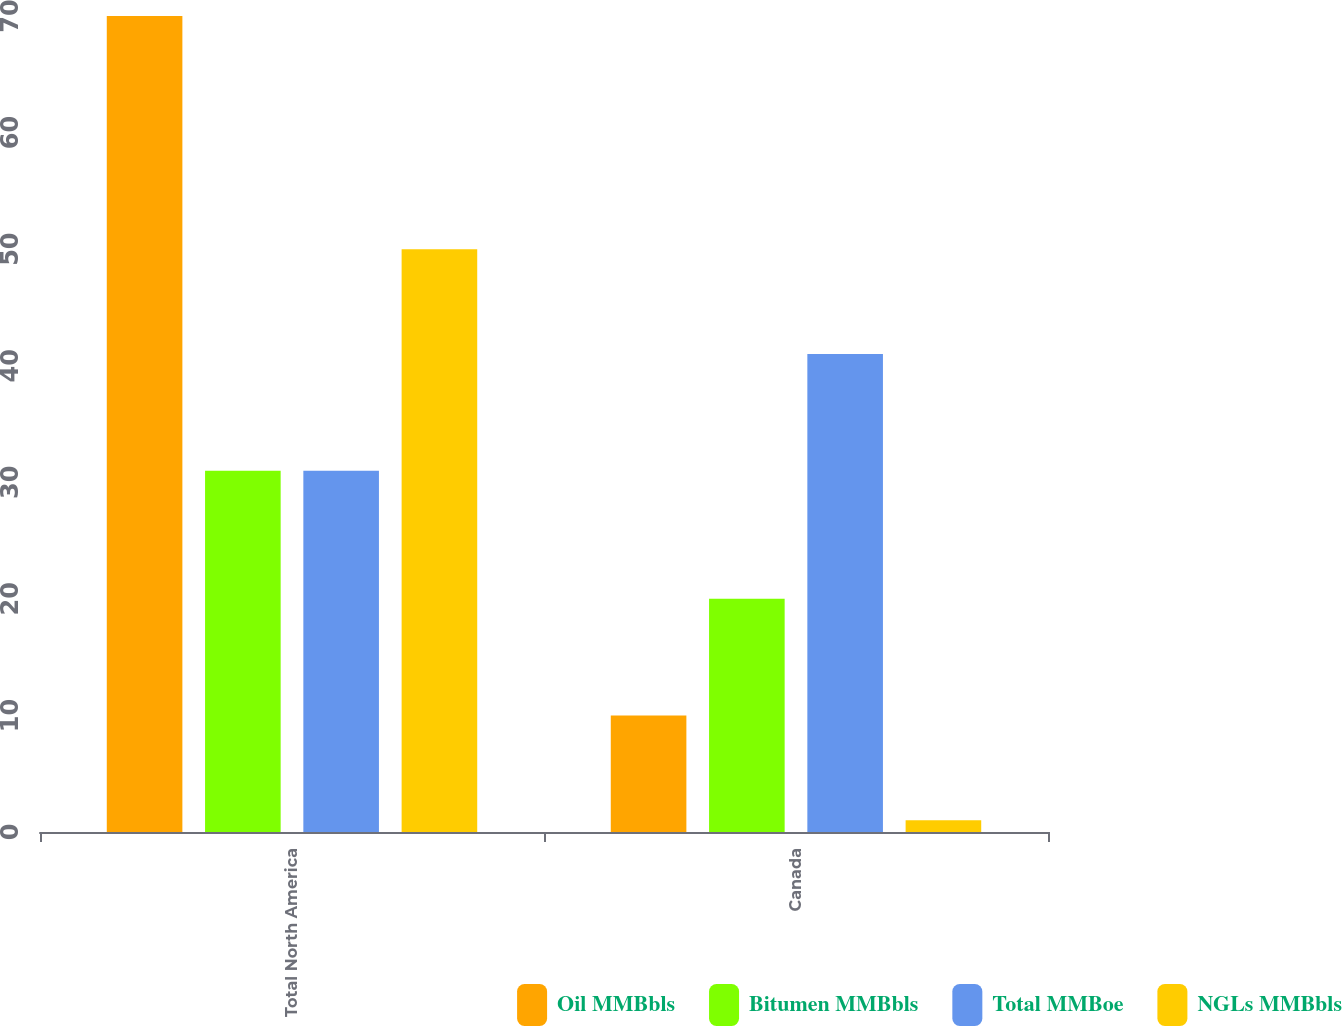Convert chart to OTSL. <chart><loc_0><loc_0><loc_500><loc_500><stacked_bar_chart><ecel><fcel>Total North America<fcel>Canada<nl><fcel>Oil MMBbls<fcel>70<fcel>10<nl><fcel>Bitumen MMBbls<fcel>31<fcel>20<nl><fcel>Total MMBoe<fcel>31<fcel>41<nl><fcel>NGLs MMBbls<fcel>50<fcel>1<nl></chart> 